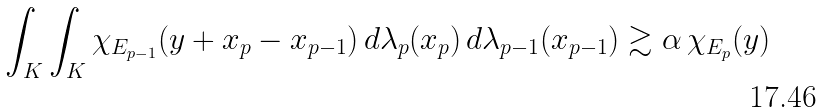<formula> <loc_0><loc_0><loc_500><loc_500>\int _ { K } \int _ { K } \chi _ { E _ { p - 1 } } ( y + x _ { p } - x _ { p - 1 } ) \, d \lambda _ { p } ( x _ { p } ) \, d \lambda _ { p - 1 } ( x _ { p - 1 } ) \gtrsim \alpha \, \chi _ { E _ { p } } ( y )</formula> 